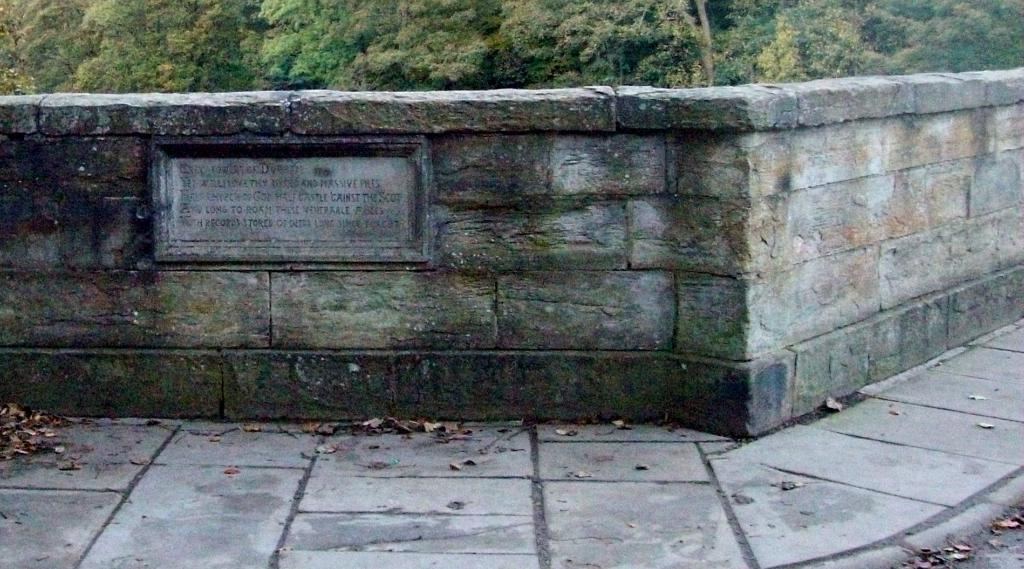What is the main structure visible in the image? There is a wall in the image. What type of natural elements can be seen at the bottom of the image? Dry leaves are visible at the bottom of the image. What type of vegetation is present in the image? There are many trees in the image, located at the top. How many sisters are playing with the creature in the image? There are no sisters or creatures present in the image. 